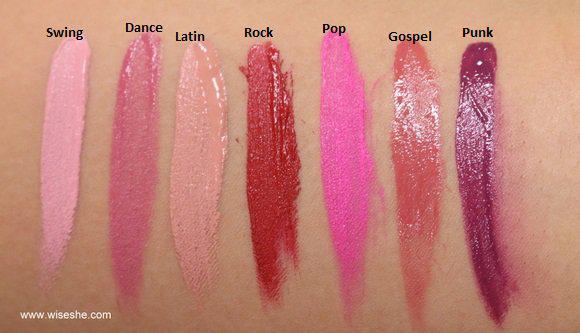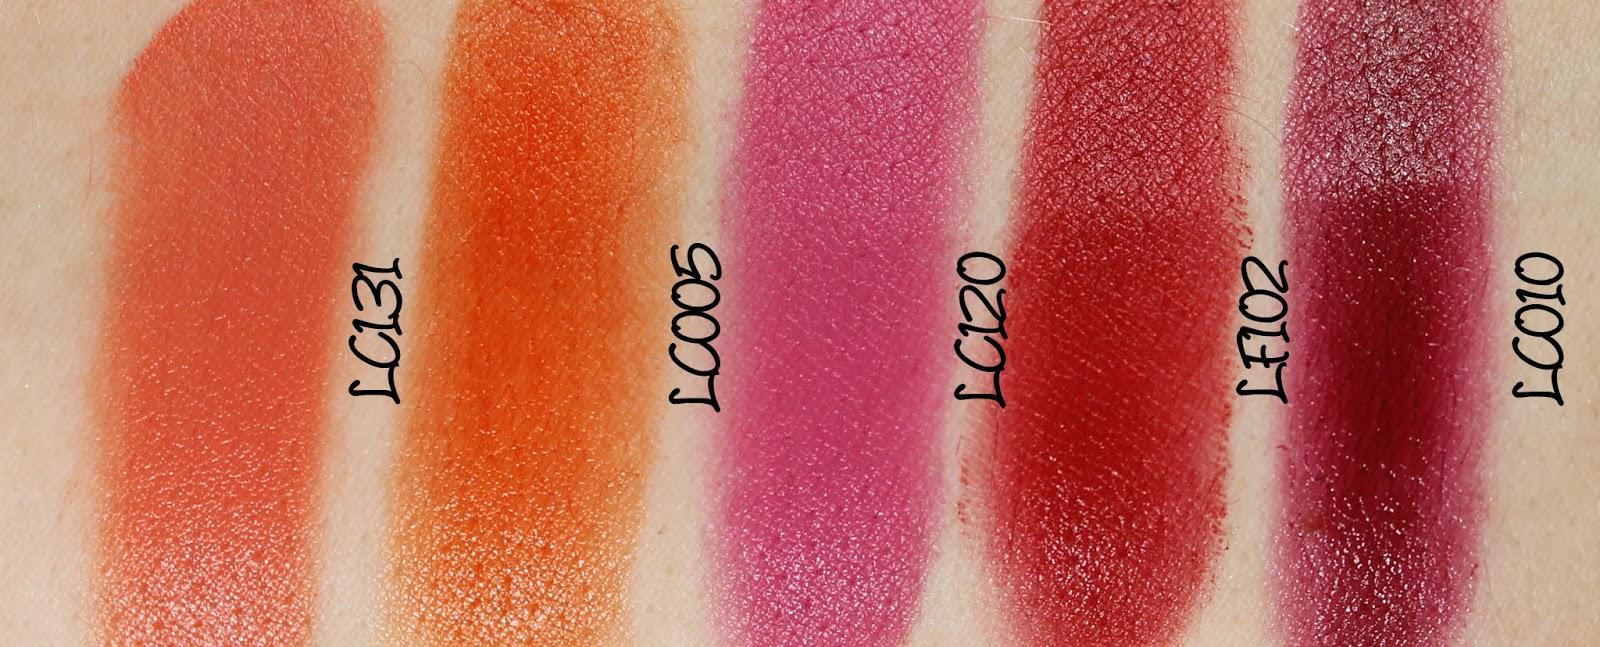The first image is the image on the left, the second image is the image on the right. Evaluate the accuracy of this statement regarding the images: "One arm has 4 swatches on it.". Is it true? Answer yes or no. No. The first image is the image on the left, the second image is the image on the right. Evaluate the accuracy of this statement regarding the images: "Each image shows lipstick stripe marks on pale skin displayed vertically, and each image includes at least five different stripes of color.". Is it true? Answer yes or no. Yes. 